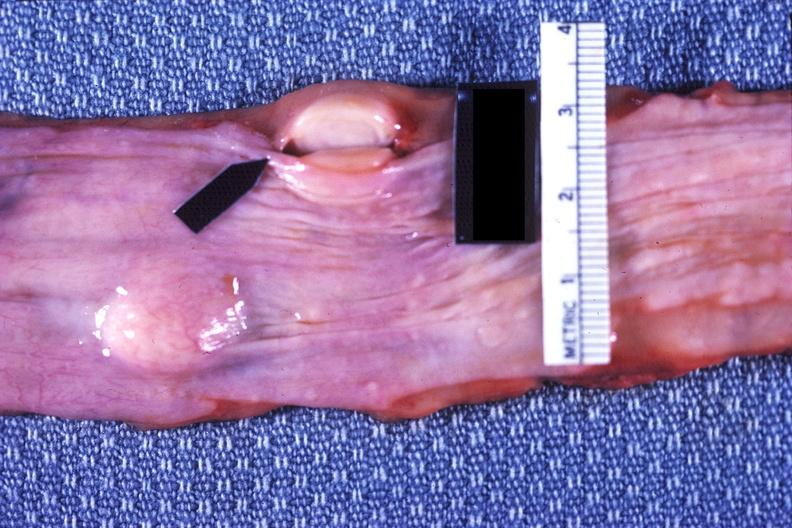does glioma show esophagus, leiomyoma?
Answer the question using a single word or phrase. No 